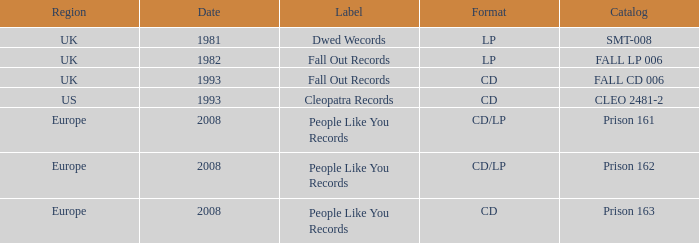Which Label has a Date smaller than 2008, and a Catalog of fall cd 006? Fall Out Records. 